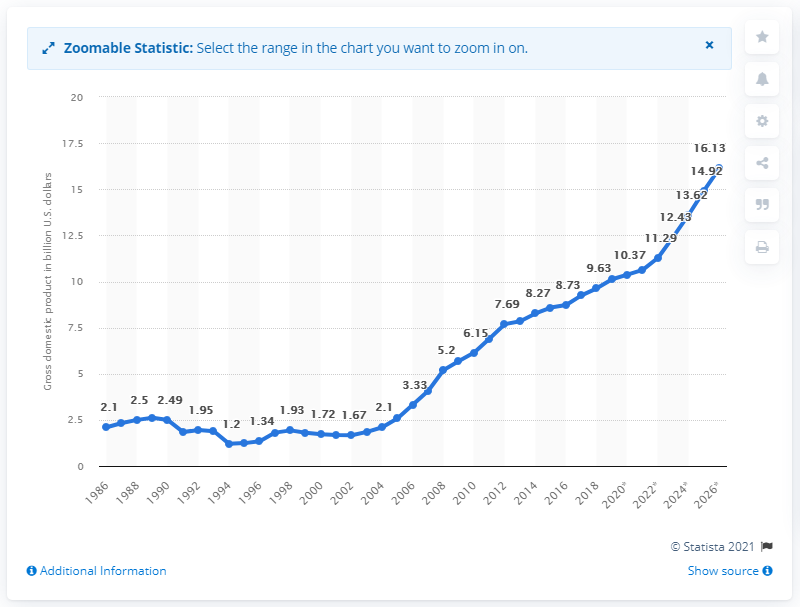Specify some key components in this picture. In 2018, Rwanda's gross domestic product (GDP) was approximately 9.63 billion dollars. 